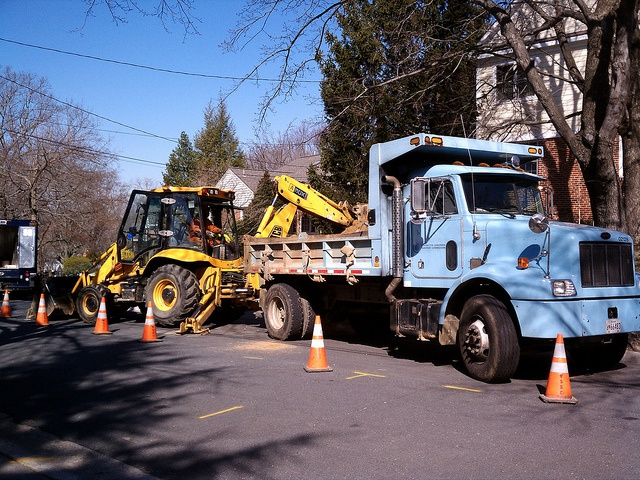Describe the objects in this image and their specific colors. I can see truck in blue, black, lightblue, and lightgray tones, truck in blue, black, darkgray, gray, and lightgray tones, and people in blue, black, maroon, and brown tones in this image. 